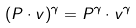<formula> <loc_0><loc_0><loc_500><loc_500>( P \cdot v ) ^ { \gamma } = P ^ { \gamma } \cdot v ^ { \gamma }</formula> 